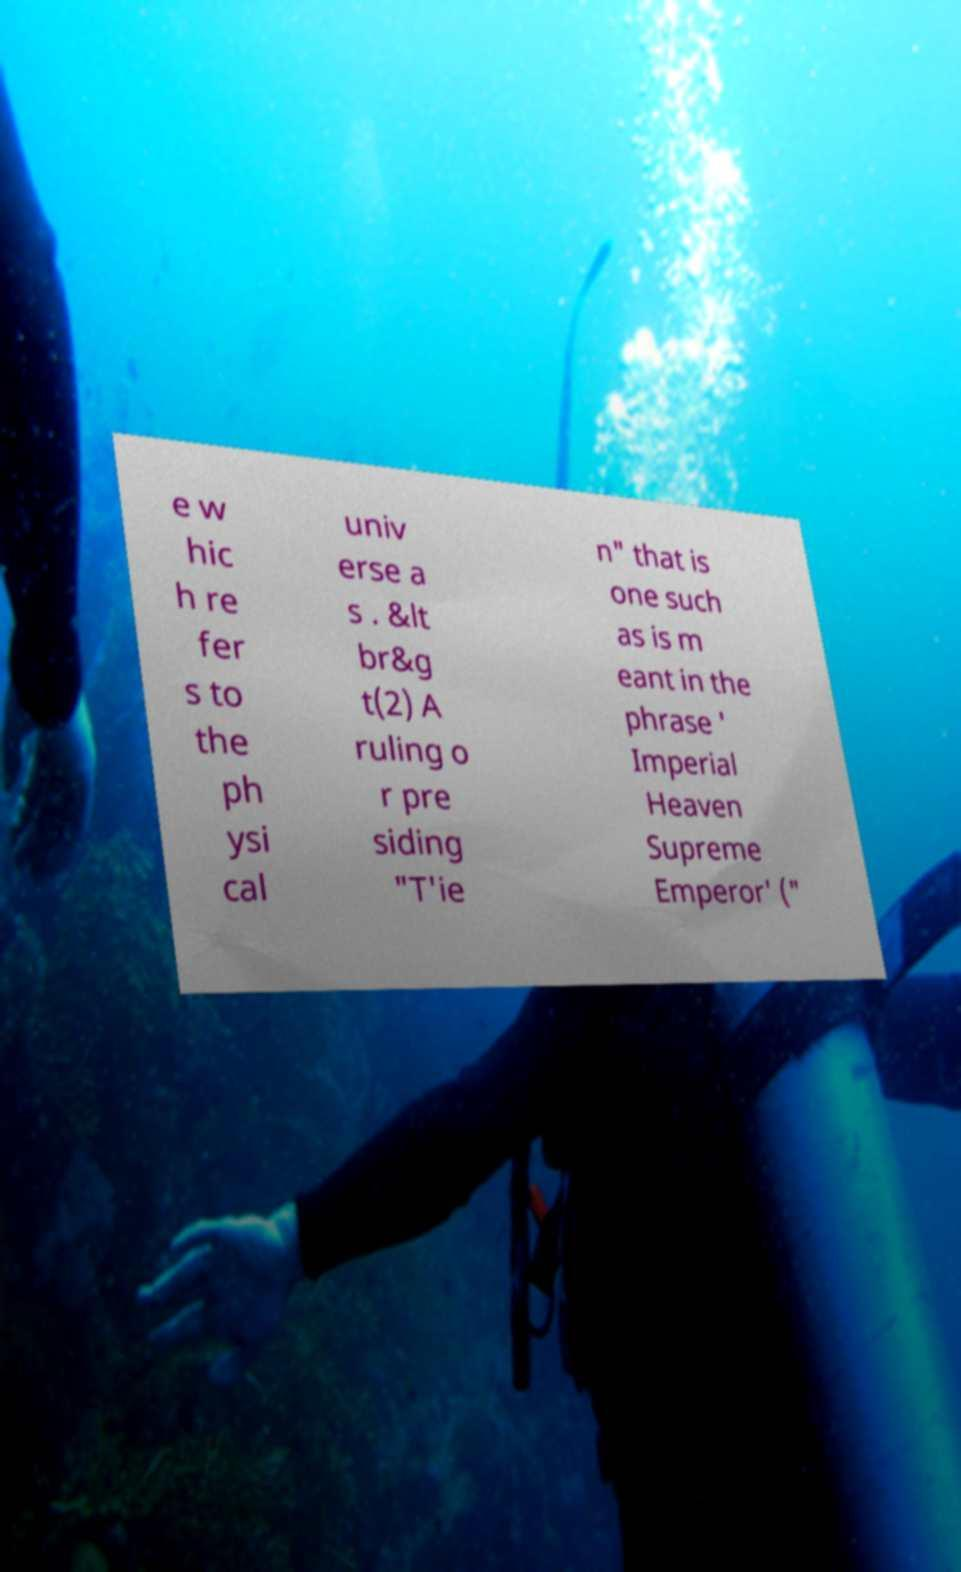Please identify and transcribe the text found in this image. e w hic h re fer s to the ph ysi cal univ erse a s . &lt br&g t(2) A ruling o r pre siding "T'ie n" that is one such as is m eant in the phrase ' Imperial Heaven Supreme Emperor' (" 